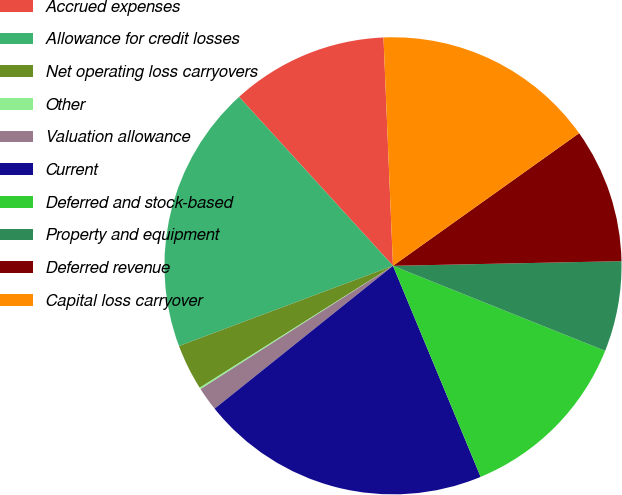<chart> <loc_0><loc_0><loc_500><loc_500><pie_chart><fcel>Accrued expenses<fcel>Allowance for credit losses<fcel>Net operating loss carryovers<fcel>Other<fcel>Valuation allowance<fcel>Current<fcel>Deferred and stock-based<fcel>Property and equipment<fcel>Deferred revenue<fcel>Capital loss carryover<nl><fcel>11.1%<fcel>18.95%<fcel>3.25%<fcel>0.11%<fcel>1.68%<fcel>20.52%<fcel>12.67%<fcel>6.39%<fcel>9.53%<fcel>15.81%<nl></chart> 